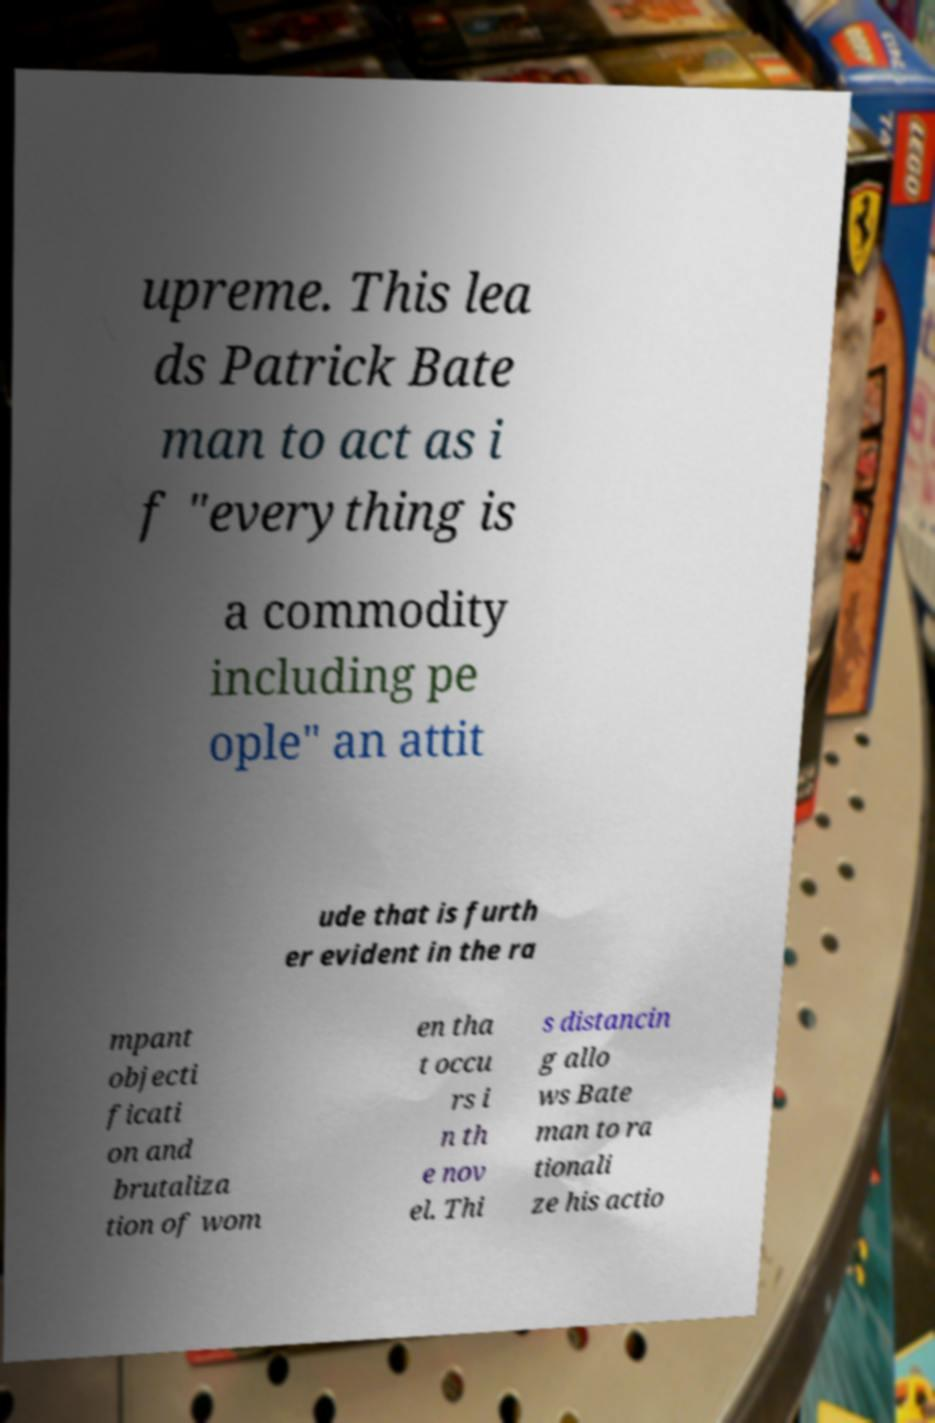For documentation purposes, I need the text within this image transcribed. Could you provide that? upreme. This lea ds Patrick Bate man to act as i f "everything is a commodity including pe ople" an attit ude that is furth er evident in the ra mpant objecti ficati on and brutaliza tion of wom en tha t occu rs i n th e nov el. Thi s distancin g allo ws Bate man to ra tionali ze his actio 